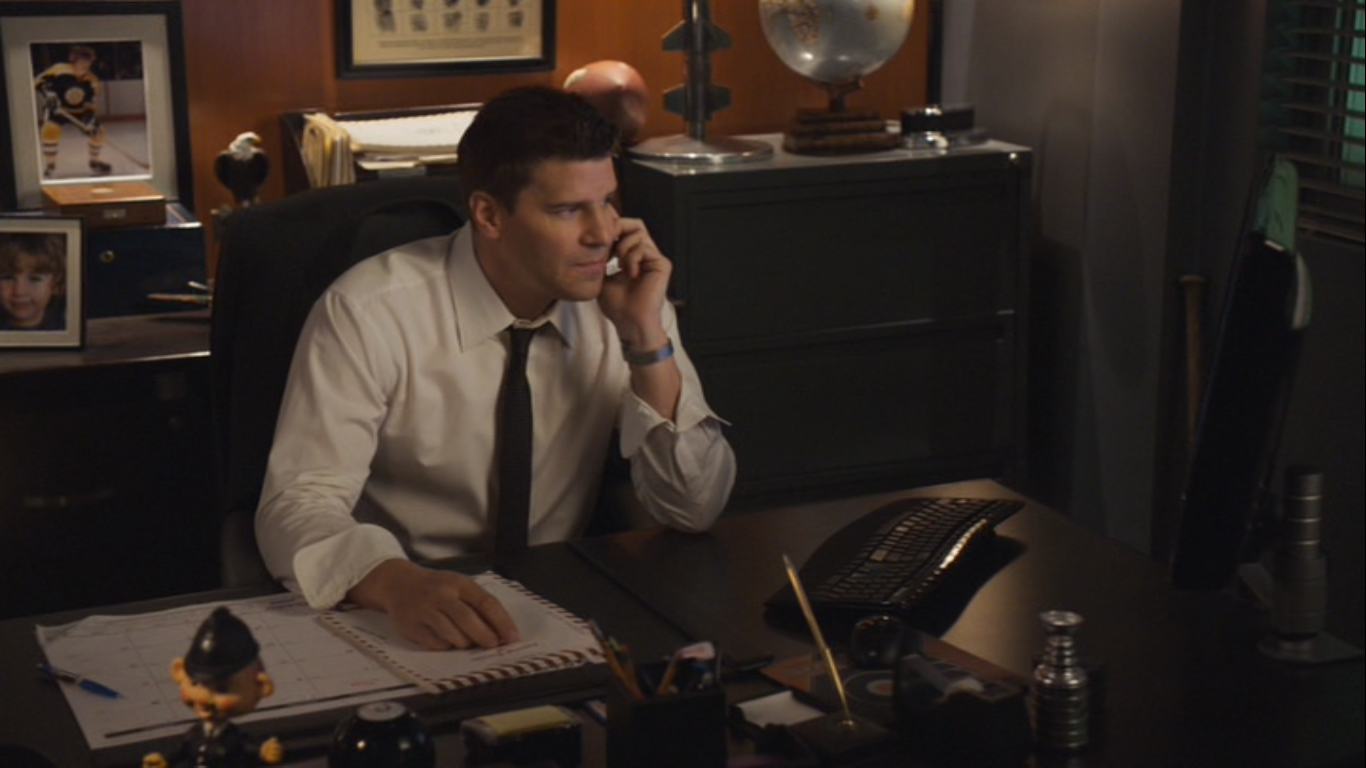What does the office tell us about the person? The office suggests that the person is a professional who values organization and perhaps has a keen interest in world affairs or travel, as indicated by the globe. The presence of personal photos hints at a connection to family, and the decor choices reflect a settled, personalized work environment. His attire indicates a role that requires formality, suggesting a position of responsibility. 